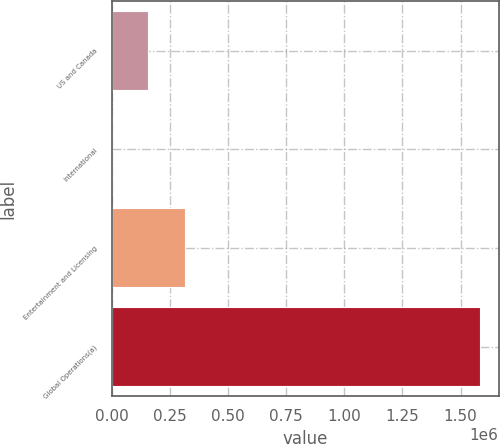Convert chart. <chart><loc_0><loc_0><loc_500><loc_500><bar_chart><fcel>US and Canada<fcel>International<fcel>Entertainment and Licensing<fcel>Global Operations(a)<nl><fcel>158380<fcel>15<fcel>316745<fcel>1.58366e+06<nl></chart> 